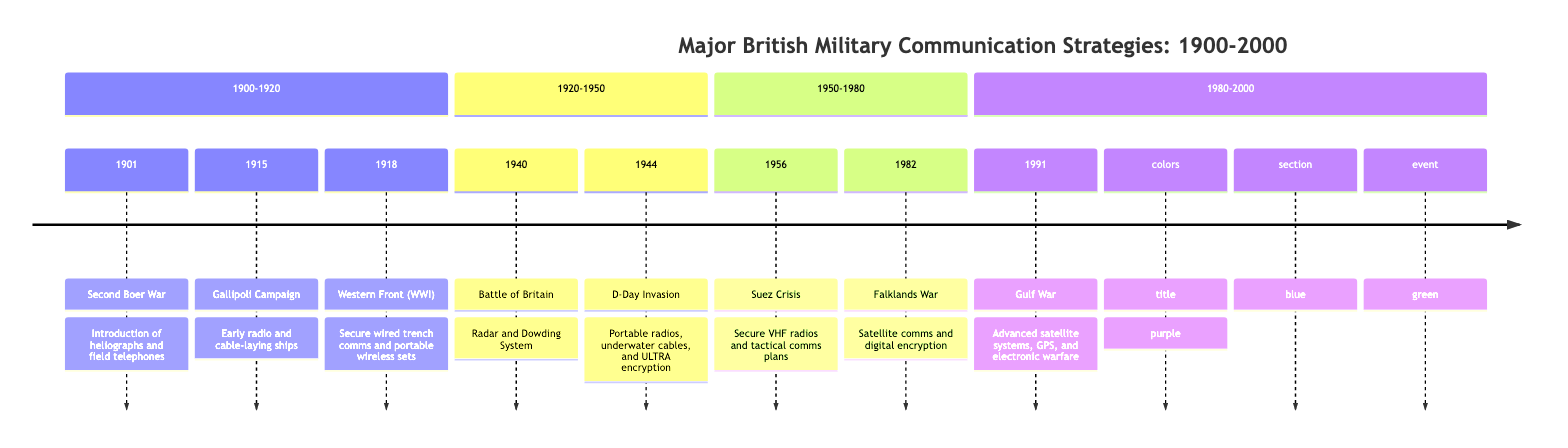What campaign took place in 1915? According to the timeline, the campaign listed for the year 1915 is the "Gallipoli Campaign."
Answer: Gallipoli Campaign What communication technology was introduced during the Second Boer War? The timeline states that the communication technologies introduced during the Second Boer War (1901) were heliographs and field telephones.
Answer: Heliographs and field telephones How many major campaigns are listed in the timeline? By counting the individual campaigns enumerated in the timeline, there are a total of eight distinct campaigns mentioned.
Answer: 8 What specific communication advancement was used during the D-Day Invasion in 1944? The timeline notes that advancements during the D-Day Invasion included the use of portable radios, underwater communication cables, and secure encryption methods known as ULTRA. Therefore, one specific advancement is portable radios.
Answer: Portable radios Which campaign saw the implementation of radar technology? The timeline indicates that the implementation of radar technology occurred during the "Battle of Britain," which took place in the year 1940.
Answer: Battle of Britain What is the time span of the campaigns listed in the timeline? The timeline shows campaigns spanning from 1901 (Second Boer War) to 1991 (Gulf War), indicating a total duration of 90 years.
Answer: 90 years What was the major communication method used in the Gulf War? In the Gulf War listed in 1991, the major communication method was the utilization of advanced satellite communication systems, which are highlighted in the timeline.
Answer: Advanced satellite communication systems During which campaign did secure VHF radios become integrated? The integration of secure VHF radios occurred during the Suez Crisis in 1956, as noted in the timeline.
Answer: Suez Crisis Which campaign is associated with the use of portable wireless sets? The timeline states that portable wireless sets were used during the "Western Front (World War I)" campaign in the year 1918.
Answer: Western Front (World War I) 